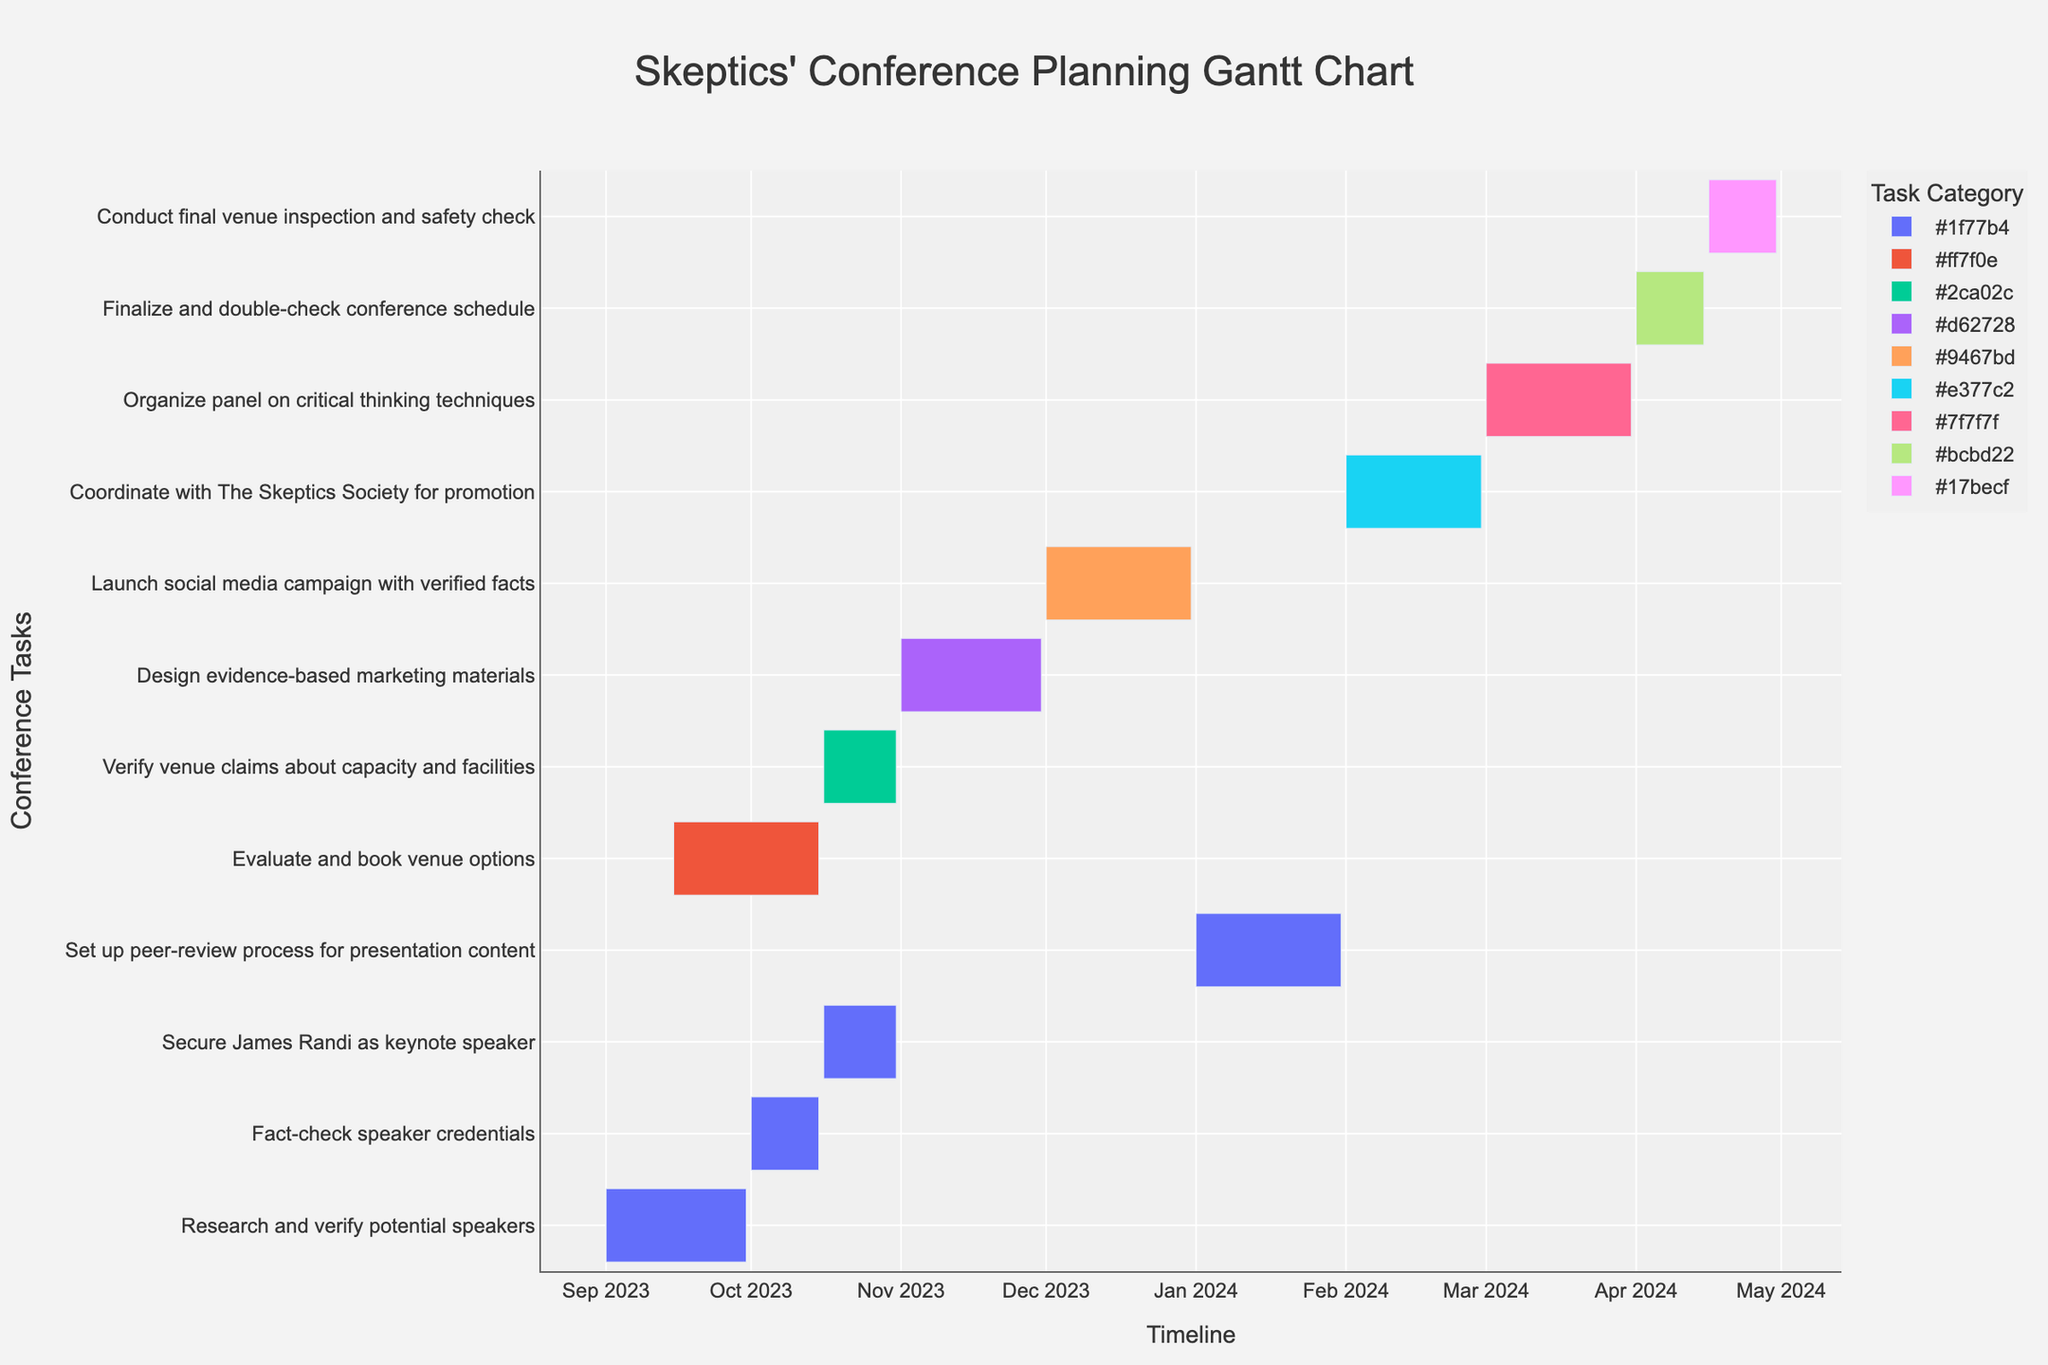Which task starts first based on the Gantt chart information? The Gantt chart shows the starting date of each task. "Research and verify potential speakers" starts on 2023-09-01, the earliest date among all tasks.
Answer: Research and verify potential speakers What is the total duration for "Secure James Randi as keynote speaker"? The Gantt chart provides the start and end dates of this task, from 2023-10-16 to 2023-10-31. Since the duration column confirms 16 days, the total duration is 16 days.
Answer: 16 days Which task has the longest duration? By examining the duration column for each task, we see that the longest duration is 31 days. Several tasks share this duration, including "Evaluate and book venue options," "Launch social media campaign with verified facts," "Set up peer-review process for presentation content," and "Organize panel on critical thinking techniques."
Answer: Evaluate and book venue options, Launch social media campaign with verified facts, Set up peer-review process for presentation content, Organize panel on critical thinking techniques How many tasks are scheduled to start in October 2023? The Gantt chart shows tasks with their specific start dates. The tasks starting in October 2023 are "Fact-check speaker credentials" on 2023-10-01, "Secure James Randi as keynote speaker" on 2023-10-16, and "Verify venue claims about capacity and facilities" on 2023-10-16. Thus, there are three tasks.
Answer: 3 tasks Are there any tasks that overlap in their schedules for the "Verify venue claims about capacity and facilities" stage? "Verify venue claims about capacity and facilities" runs from 2023-10-16 to 2023-10-31. Checking the Gantt chart, we see that "Secure James Randi as keynote speaker" also runs from 2023-10-16 to 2023-10-31, so these two tasks overlap during this period.
Answer: Yes, Secure James Randi as keynote speaker What is the total duration from the earliest start date to the latest end date in the chart? The Gantt chart shows the earliest start date is 2023-09-01 ("Research and verify potential speakers") and the latest end date is 2024-04-30 ("Conduct final venue inspection and safety check"). Calculating the total duration between these two dates: from 2023-09-01 to 2024-04-30 is approximately 243 days.
Answer: 243 days Which task directly follows "Fact-check speaker credentials"? According to the Gantt chart, "Fact-check speaker credentials" ends on 2023-10-15. The next task starting after this date is "Secure James Randi as keynote speaker" on 2023-10-16.
Answer: Secure James Randi as keynote speaker Do any tasks fall entirely within the month of April 2024? By looking at the Gantt chart for tasks in April 2024, we see “Finalize and double-check conference schedule” from 2024-04-01 to 2024-04-15, and “Conduct final venue inspection and safety check” from 2024-04-16 to 2024-04-30. Both tasks fall entirely within April 2024.
Answer: Yes, Finalize and double-check conference schedule, Conduct final venue inspection and safety check 